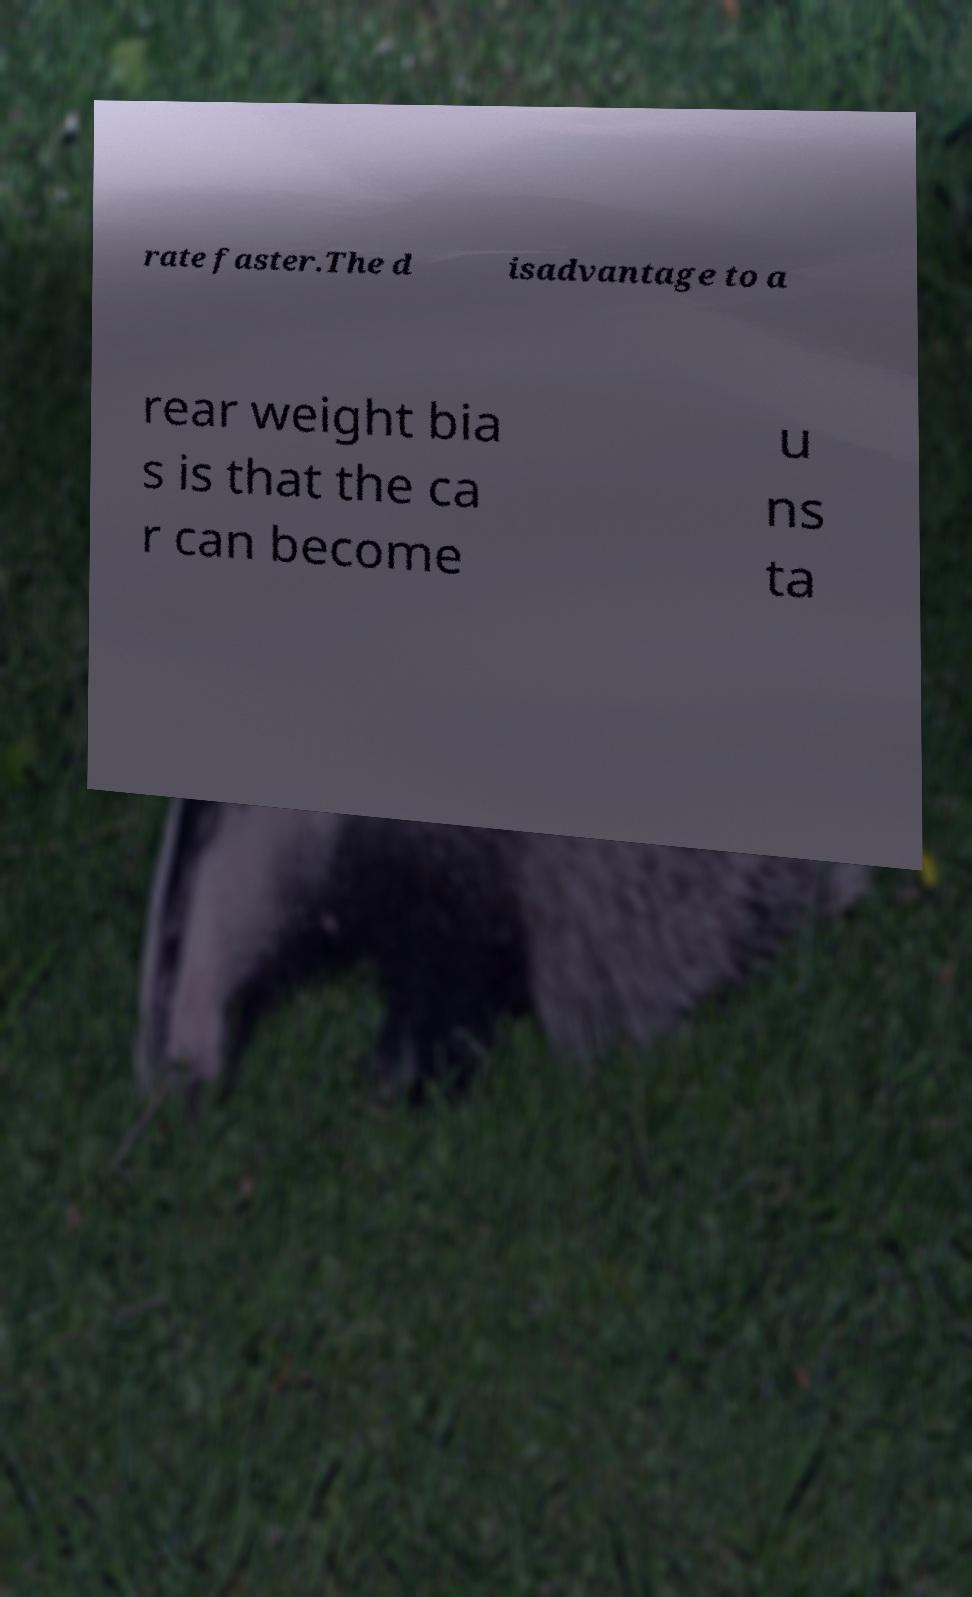I need the written content from this picture converted into text. Can you do that? rate faster.The d isadvantage to a rear weight bia s is that the ca r can become u ns ta 